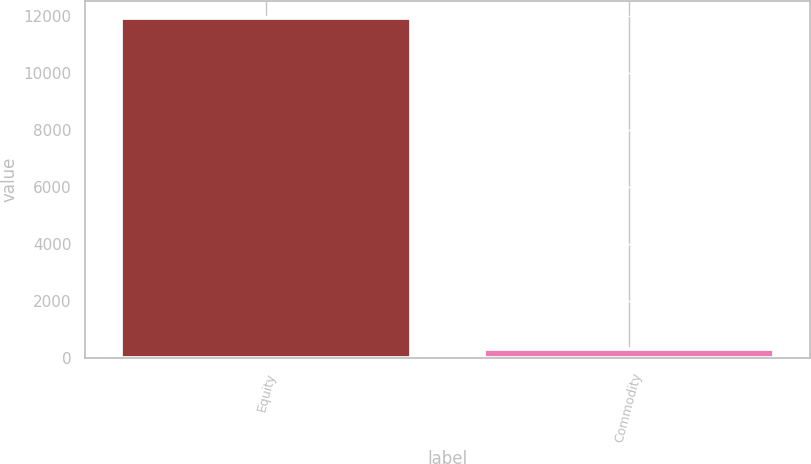Convert chart to OTSL. <chart><loc_0><loc_0><loc_500><loc_500><bar_chart><fcel>Equity<fcel>Commodity<nl><fcel>11936<fcel>310<nl></chart> 